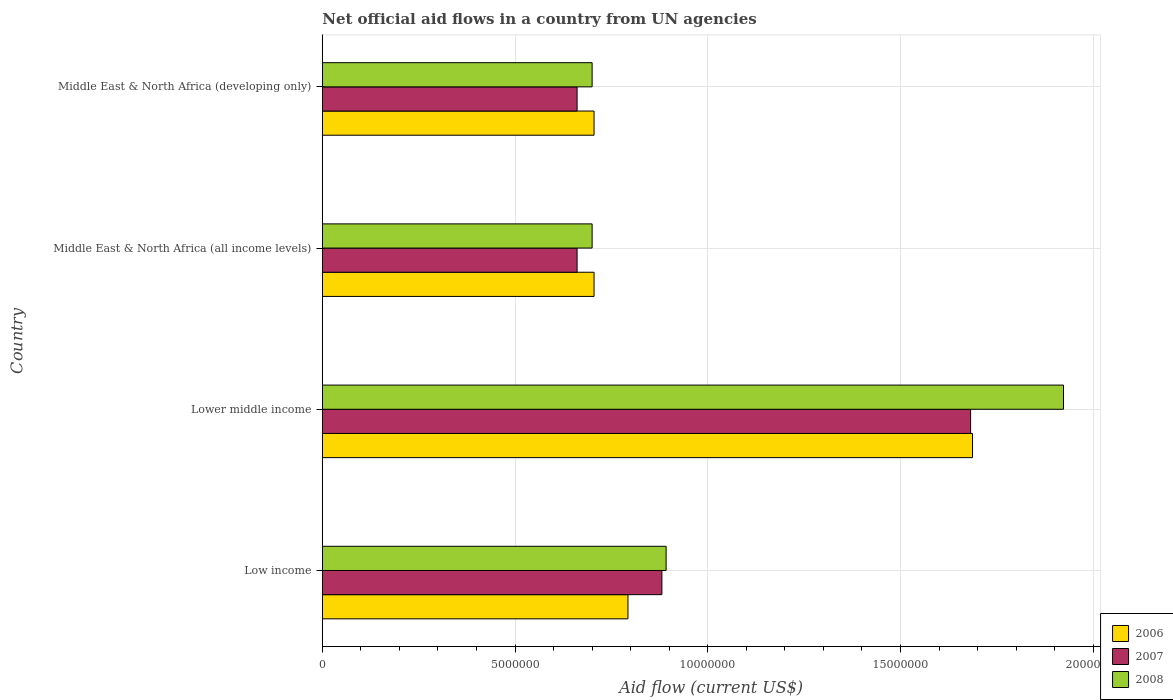Are the number of bars per tick equal to the number of legend labels?
Provide a succinct answer. Yes. Are the number of bars on each tick of the Y-axis equal?
Offer a terse response. Yes. How many bars are there on the 1st tick from the top?
Offer a terse response. 3. How many bars are there on the 2nd tick from the bottom?
Provide a succinct answer. 3. What is the label of the 1st group of bars from the top?
Offer a terse response. Middle East & North Africa (developing only). In how many cases, is the number of bars for a given country not equal to the number of legend labels?
Keep it short and to the point. 0. What is the net official aid flow in 2007 in Lower middle income?
Your response must be concise. 1.68e+07. Across all countries, what is the maximum net official aid flow in 2008?
Your response must be concise. 1.92e+07. Across all countries, what is the minimum net official aid flow in 2006?
Provide a succinct answer. 7.05e+06. In which country was the net official aid flow in 2006 maximum?
Provide a succinct answer. Lower middle income. In which country was the net official aid flow in 2006 minimum?
Offer a very short reply. Middle East & North Africa (all income levels). What is the total net official aid flow in 2007 in the graph?
Your response must be concise. 3.88e+07. What is the difference between the net official aid flow in 2006 in Low income and that in Lower middle income?
Your response must be concise. -8.94e+06. What is the difference between the net official aid flow in 2008 in Middle East & North Africa (developing only) and the net official aid flow in 2007 in Low income?
Provide a short and direct response. -1.81e+06. What is the average net official aid flow in 2006 per country?
Ensure brevity in your answer.  9.72e+06. What is the difference between the net official aid flow in 2007 and net official aid flow in 2008 in Middle East & North Africa (all income levels)?
Provide a short and direct response. -3.90e+05. In how many countries, is the net official aid flow in 2007 greater than 4000000 US$?
Offer a terse response. 4. What is the ratio of the net official aid flow in 2006 in Middle East & North Africa (all income levels) to that in Middle East & North Africa (developing only)?
Give a very brief answer. 1. Is the difference between the net official aid flow in 2007 in Lower middle income and Middle East & North Africa (developing only) greater than the difference between the net official aid flow in 2008 in Lower middle income and Middle East & North Africa (developing only)?
Your response must be concise. No. What is the difference between the highest and the second highest net official aid flow in 2008?
Offer a terse response. 1.03e+07. What is the difference between the highest and the lowest net official aid flow in 2008?
Keep it short and to the point. 1.22e+07. Is the sum of the net official aid flow in 2007 in Lower middle income and Middle East & North Africa (developing only) greater than the maximum net official aid flow in 2008 across all countries?
Keep it short and to the point. Yes. Are all the bars in the graph horizontal?
Your answer should be compact. Yes. How many countries are there in the graph?
Give a very brief answer. 4. Does the graph contain grids?
Keep it short and to the point. Yes. Where does the legend appear in the graph?
Your response must be concise. Bottom right. What is the title of the graph?
Your answer should be compact. Net official aid flows in a country from UN agencies. Does "1982" appear as one of the legend labels in the graph?
Offer a very short reply. No. What is the Aid flow (current US$) of 2006 in Low income?
Provide a succinct answer. 7.93e+06. What is the Aid flow (current US$) in 2007 in Low income?
Keep it short and to the point. 8.81e+06. What is the Aid flow (current US$) in 2008 in Low income?
Keep it short and to the point. 8.92e+06. What is the Aid flow (current US$) of 2006 in Lower middle income?
Give a very brief answer. 1.69e+07. What is the Aid flow (current US$) of 2007 in Lower middle income?
Your response must be concise. 1.68e+07. What is the Aid flow (current US$) in 2008 in Lower middle income?
Your response must be concise. 1.92e+07. What is the Aid flow (current US$) of 2006 in Middle East & North Africa (all income levels)?
Offer a very short reply. 7.05e+06. What is the Aid flow (current US$) in 2007 in Middle East & North Africa (all income levels)?
Offer a very short reply. 6.61e+06. What is the Aid flow (current US$) in 2008 in Middle East & North Africa (all income levels)?
Give a very brief answer. 7.00e+06. What is the Aid flow (current US$) in 2006 in Middle East & North Africa (developing only)?
Provide a succinct answer. 7.05e+06. What is the Aid flow (current US$) in 2007 in Middle East & North Africa (developing only)?
Offer a very short reply. 6.61e+06. What is the Aid flow (current US$) of 2008 in Middle East & North Africa (developing only)?
Offer a very short reply. 7.00e+06. Across all countries, what is the maximum Aid flow (current US$) of 2006?
Give a very brief answer. 1.69e+07. Across all countries, what is the maximum Aid flow (current US$) in 2007?
Provide a short and direct response. 1.68e+07. Across all countries, what is the maximum Aid flow (current US$) of 2008?
Your answer should be compact. 1.92e+07. Across all countries, what is the minimum Aid flow (current US$) in 2006?
Your answer should be compact. 7.05e+06. Across all countries, what is the minimum Aid flow (current US$) in 2007?
Your answer should be compact. 6.61e+06. Across all countries, what is the minimum Aid flow (current US$) of 2008?
Give a very brief answer. 7.00e+06. What is the total Aid flow (current US$) in 2006 in the graph?
Your answer should be very brief. 3.89e+07. What is the total Aid flow (current US$) of 2007 in the graph?
Your answer should be very brief. 3.88e+07. What is the total Aid flow (current US$) of 2008 in the graph?
Ensure brevity in your answer.  4.22e+07. What is the difference between the Aid flow (current US$) of 2006 in Low income and that in Lower middle income?
Your answer should be compact. -8.94e+06. What is the difference between the Aid flow (current US$) in 2007 in Low income and that in Lower middle income?
Offer a terse response. -8.01e+06. What is the difference between the Aid flow (current US$) in 2008 in Low income and that in Lower middle income?
Provide a succinct answer. -1.03e+07. What is the difference between the Aid flow (current US$) of 2006 in Low income and that in Middle East & North Africa (all income levels)?
Your response must be concise. 8.80e+05. What is the difference between the Aid flow (current US$) in 2007 in Low income and that in Middle East & North Africa (all income levels)?
Your answer should be very brief. 2.20e+06. What is the difference between the Aid flow (current US$) of 2008 in Low income and that in Middle East & North Africa (all income levels)?
Your response must be concise. 1.92e+06. What is the difference between the Aid flow (current US$) in 2006 in Low income and that in Middle East & North Africa (developing only)?
Offer a very short reply. 8.80e+05. What is the difference between the Aid flow (current US$) of 2007 in Low income and that in Middle East & North Africa (developing only)?
Ensure brevity in your answer.  2.20e+06. What is the difference between the Aid flow (current US$) of 2008 in Low income and that in Middle East & North Africa (developing only)?
Provide a succinct answer. 1.92e+06. What is the difference between the Aid flow (current US$) of 2006 in Lower middle income and that in Middle East & North Africa (all income levels)?
Provide a short and direct response. 9.82e+06. What is the difference between the Aid flow (current US$) in 2007 in Lower middle income and that in Middle East & North Africa (all income levels)?
Offer a terse response. 1.02e+07. What is the difference between the Aid flow (current US$) of 2008 in Lower middle income and that in Middle East & North Africa (all income levels)?
Provide a succinct answer. 1.22e+07. What is the difference between the Aid flow (current US$) in 2006 in Lower middle income and that in Middle East & North Africa (developing only)?
Offer a very short reply. 9.82e+06. What is the difference between the Aid flow (current US$) of 2007 in Lower middle income and that in Middle East & North Africa (developing only)?
Ensure brevity in your answer.  1.02e+07. What is the difference between the Aid flow (current US$) of 2008 in Lower middle income and that in Middle East & North Africa (developing only)?
Your answer should be compact. 1.22e+07. What is the difference between the Aid flow (current US$) of 2006 in Middle East & North Africa (all income levels) and that in Middle East & North Africa (developing only)?
Your answer should be compact. 0. What is the difference between the Aid flow (current US$) in 2008 in Middle East & North Africa (all income levels) and that in Middle East & North Africa (developing only)?
Your answer should be compact. 0. What is the difference between the Aid flow (current US$) in 2006 in Low income and the Aid flow (current US$) in 2007 in Lower middle income?
Give a very brief answer. -8.89e+06. What is the difference between the Aid flow (current US$) in 2006 in Low income and the Aid flow (current US$) in 2008 in Lower middle income?
Give a very brief answer. -1.13e+07. What is the difference between the Aid flow (current US$) in 2007 in Low income and the Aid flow (current US$) in 2008 in Lower middle income?
Offer a terse response. -1.04e+07. What is the difference between the Aid flow (current US$) in 2006 in Low income and the Aid flow (current US$) in 2007 in Middle East & North Africa (all income levels)?
Offer a terse response. 1.32e+06. What is the difference between the Aid flow (current US$) of 2006 in Low income and the Aid flow (current US$) of 2008 in Middle East & North Africa (all income levels)?
Ensure brevity in your answer.  9.30e+05. What is the difference between the Aid flow (current US$) of 2007 in Low income and the Aid flow (current US$) of 2008 in Middle East & North Africa (all income levels)?
Keep it short and to the point. 1.81e+06. What is the difference between the Aid flow (current US$) in 2006 in Low income and the Aid flow (current US$) in 2007 in Middle East & North Africa (developing only)?
Your response must be concise. 1.32e+06. What is the difference between the Aid flow (current US$) in 2006 in Low income and the Aid flow (current US$) in 2008 in Middle East & North Africa (developing only)?
Offer a terse response. 9.30e+05. What is the difference between the Aid flow (current US$) of 2007 in Low income and the Aid flow (current US$) of 2008 in Middle East & North Africa (developing only)?
Your answer should be compact. 1.81e+06. What is the difference between the Aid flow (current US$) in 2006 in Lower middle income and the Aid flow (current US$) in 2007 in Middle East & North Africa (all income levels)?
Make the answer very short. 1.03e+07. What is the difference between the Aid flow (current US$) of 2006 in Lower middle income and the Aid flow (current US$) of 2008 in Middle East & North Africa (all income levels)?
Provide a succinct answer. 9.87e+06. What is the difference between the Aid flow (current US$) in 2007 in Lower middle income and the Aid flow (current US$) in 2008 in Middle East & North Africa (all income levels)?
Offer a very short reply. 9.82e+06. What is the difference between the Aid flow (current US$) in 2006 in Lower middle income and the Aid flow (current US$) in 2007 in Middle East & North Africa (developing only)?
Your answer should be very brief. 1.03e+07. What is the difference between the Aid flow (current US$) in 2006 in Lower middle income and the Aid flow (current US$) in 2008 in Middle East & North Africa (developing only)?
Offer a terse response. 9.87e+06. What is the difference between the Aid flow (current US$) of 2007 in Lower middle income and the Aid flow (current US$) of 2008 in Middle East & North Africa (developing only)?
Offer a terse response. 9.82e+06. What is the difference between the Aid flow (current US$) in 2006 in Middle East & North Africa (all income levels) and the Aid flow (current US$) in 2008 in Middle East & North Africa (developing only)?
Keep it short and to the point. 5.00e+04. What is the difference between the Aid flow (current US$) of 2007 in Middle East & North Africa (all income levels) and the Aid flow (current US$) of 2008 in Middle East & North Africa (developing only)?
Offer a very short reply. -3.90e+05. What is the average Aid flow (current US$) in 2006 per country?
Your response must be concise. 9.72e+06. What is the average Aid flow (current US$) of 2007 per country?
Provide a succinct answer. 9.71e+06. What is the average Aid flow (current US$) of 2008 per country?
Your response must be concise. 1.05e+07. What is the difference between the Aid flow (current US$) in 2006 and Aid flow (current US$) in 2007 in Low income?
Offer a terse response. -8.80e+05. What is the difference between the Aid flow (current US$) in 2006 and Aid flow (current US$) in 2008 in Low income?
Your response must be concise. -9.90e+05. What is the difference between the Aid flow (current US$) in 2006 and Aid flow (current US$) in 2008 in Lower middle income?
Your response must be concise. -2.36e+06. What is the difference between the Aid flow (current US$) of 2007 and Aid flow (current US$) of 2008 in Lower middle income?
Ensure brevity in your answer.  -2.41e+06. What is the difference between the Aid flow (current US$) in 2006 and Aid flow (current US$) in 2007 in Middle East & North Africa (all income levels)?
Make the answer very short. 4.40e+05. What is the difference between the Aid flow (current US$) of 2007 and Aid flow (current US$) of 2008 in Middle East & North Africa (all income levels)?
Your response must be concise. -3.90e+05. What is the difference between the Aid flow (current US$) in 2006 and Aid flow (current US$) in 2008 in Middle East & North Africa (developing only)?
Your answer should be very brief. 5.00e+04. What is the difference between the Aid flow (current US$) of 2007 and Aid flow (current US$) of 2008 in Middle East & North Africa (developing only)?
Your answer should be compact. -3.90e+05. What is the ratio of the Aid flow (current US$) of 2006 in Low income to that in Lower middle income?
Provide a succinct answer. 0.47. What is the ratio of the Aid flow (current US$) of 2007 in Low income to that in Lower middle income?
Offer a very short reply. 0.52. What is the ratio of the Aid flow (current US$) of 2008 in Low income to that in Lower middle income?
Your answer should be compact. 0.46. What is the ratio of the Aid flow (current US$) in 2006 in Low income to that in Middle East & North Africa (all income levels)?
Your response must be concise. 1.12. What is the ratio of the Aid flow (current US$) in 2007 in Low income to that in Middle East & North Africa (all income levels)?
Give a very brief answer. 1.33. What is the ratio of the Aid flow (current US$) in 2008 in Low income to that in Middle East & North Africa (all income levels)?
Offer a very short reply. 1.27. What is the ratio of the Aid flow (current US$) in 2006 in Low income to that in Middle East & North Africa (developing only)?
Your response must be concise. 1.12. What is the ratio of the Aid flow (current US$) of 2007 in Low income to that in Middle East & North Africa (developing only)?
Provide a succinct answer. 1.33. What is the ratio of the Aid flow (current US$) of 2008 in Low income to that in Middle East & North Africa (developing only)?
Provide a short and direct response. 1.27. What is the ratio of the Aid flow (current US$) of 2006 in Lower middle income to that in Middle East & North Africa (all income levels)?
Your answer should be very brief. 2.39. What is the ratio of the Aid flow (current US$) of 2007 in Lower middle income to that in Middle East & North Africa (all income levels)?
Give a very brief answer. 2.54. What is the ratio of the Aid flow (current US$) of 2008 in Lower middle income to that in Middle East & North Africa (all income levels)?
Ensure brevity in your answer.  2.75. What is the ratio of the Aid flow (current US$) in 2006 in Lower middle income to that in Middle East & North Africa (developing only)?
Keep it short and to the point. 2.39. What is the ratio of the Aid flow (current US$) in 2007 in Lower middle income to that in Middle East & North Africa (developing only)?
Your answer should be compact. 2.54. What is the ratio of the Aid flow (current US$) of 2008 in Lower middle income to that in Middle East & North Africa (developing only)?
Your answer should be compact. 2.75. What is the ratio of the Aid flow (current US$) of 2007 in Middle East & North Africa (all income levels) to that in Middle East & North Africa (developing only)?
Keep it short and to the point. 1. What is the ratio of the Aid flow (current US$) in 2008 in Middle East & North Africa (all income levels) to that in Middle East & North Africa (developing only)?
Ensure brevity in your answer.  1. What is the difference between the highest and the second highest Aid flow (current US$) in 2006?
Give a very brief answer. 8.94e+06. What is the difference between the highest and the second highest Aid flow (current US$) in 2007?
Keep it short and to the point. 8.01e+06. What is the difference between the highest and the second highest Aid flow (current US$) of 2008?
Provide a short and direct response. 1.03e+07. What is the difference between the highest and the lowest Aid flow (current US$) of 2006?
Your answer should be compact. 9.82e+06. What is the difference between the highest and the lowest Aid flow (current US$) in 2007?
Offer a very short reply. 1.02e+07. What is the difference between the highest and the lowest Aid flow (current US$) in 2008?
Ensure brevity in your answer.  1.22e+07. 